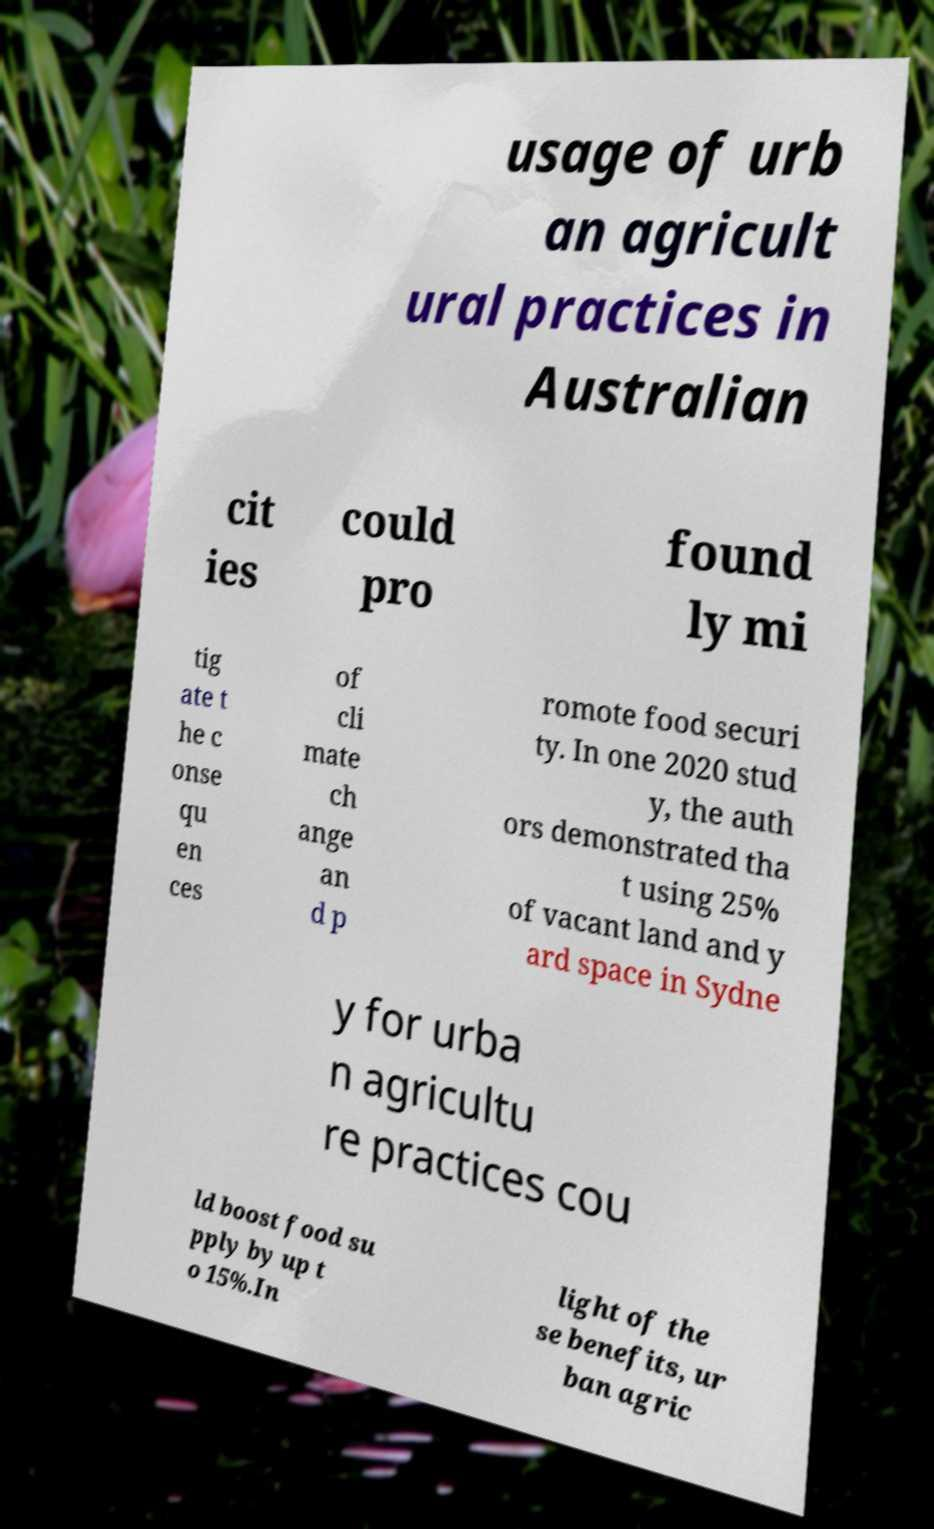What messages or text are displayed in this image? I need them in a readable, typed format. usage of urb an agricult ural practices in Australian cit ies could pro found ly mi tig ate t he c onse qu en ces of cli mate ch ange an d p romote food securi ty. In one 2020 stud y, the auth ors demonstrated tha t using 25% of vacant land and y ard space in Sydne y for urba n agricultu re practices cou ld boost food su pply by up t o 15%.In light of the se benefits, ur ban agric 